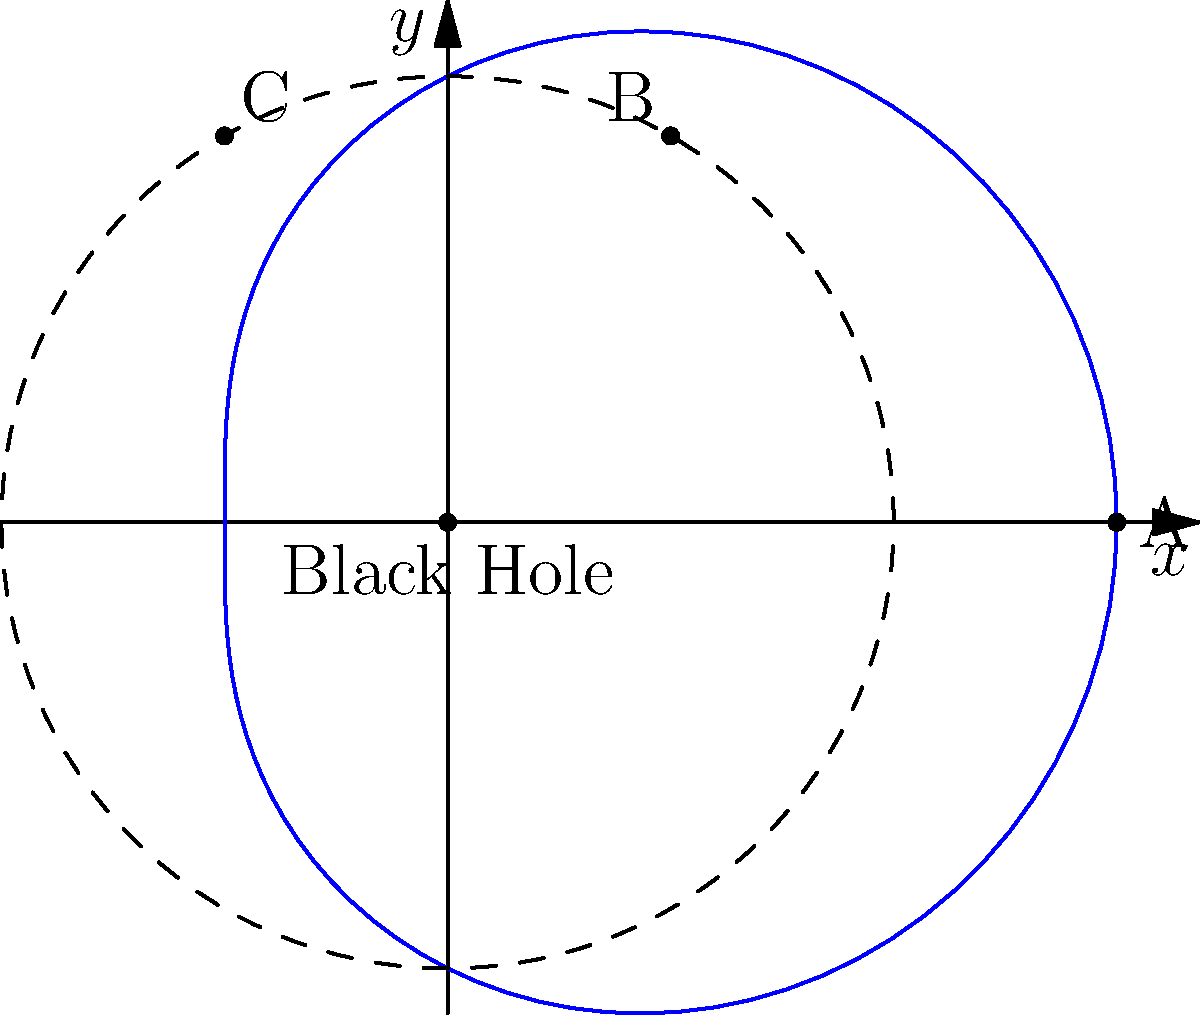A spacecraft is studying a black hole with Schwarzschild radius $R_s = 2$ units. The spacecraft follows a polar orbit described by $r(\theta) = 2 + \cos(\theta)$. Calculate the ratio of proper time experienced by an observer on the spacecraft to coordinate time when the spacecraft is at points A $(3,0)$, B $(1,\sqrt{3})$, and C $(-1,\sqrt{3})$. Which point experiences the strongest time dilation effect? To solve this problem, we'll use the time dilation formula for a Schwarzschild black hole:

$$\frac{d\tau}{dt} = \sqrt{1 - \frac{R_s}{r}}$$

where $\tau$ is proper time, $t$ is coordinate time, $R_s$ is the Schwarzschild radius, and $r$ is the radial distance from the black hole.

Step 1: Calculate the radial distances for each point.
A: $r_A = 3$
B: $r_B = \sqrt{1^2 + (\sqrt{3})^2} = 2$
C: $r_C = \sqrt{(-1)^2 + (\sqrt{3})^2} = 2$

Step 2: Calculate the time dilation ratio for each point.

Point A:
$$\frac{d\tau_A}{dt} = \sqrt{1 - \frac{2}{3}} = \sqrt{\frac{1}{3}} \approx 0.577$$

Point B:
$$\frac{d\tau_B}{dt} = \sqrt{1 - \frac{2}{2}} = 0$$

Point C:
$$\frac{d\tau_C}{dt} = \sqrt{1 - \frac{2}{2}} = 0$$

Step 3: Compare the ratios.

The smaller the ratio, the stronger the time dilation effect. Points B and C have a ratio of 0, which means time effectively stops at these points (they are on the event horizon). Point A has a non-zero ratio, indicating less time dilation.

Therefore, points B and C experience the strongest time dilation effect.
Answer: Points B and C (event horizon) 